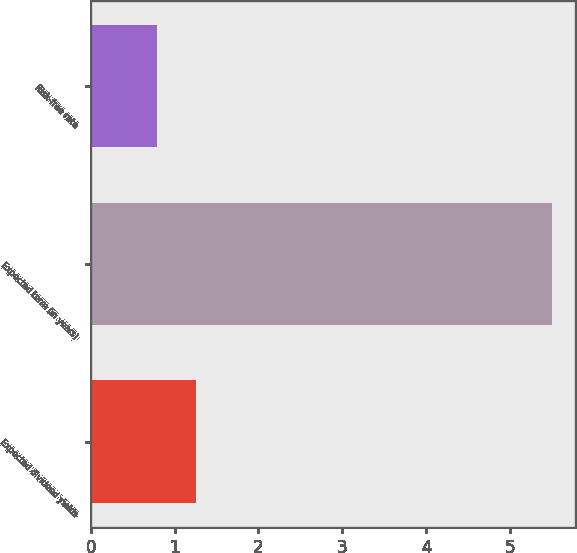Convert chart. <chart><loc_0><loc_0><loc_500><loc_500><bar_chart><fcel>Expected dividend yields<fcel>Expected term (in years)<fcel>Risk-free rate<nl><fcel>1.26<fcel>5.5<fcel>0.79<nl></chart> 